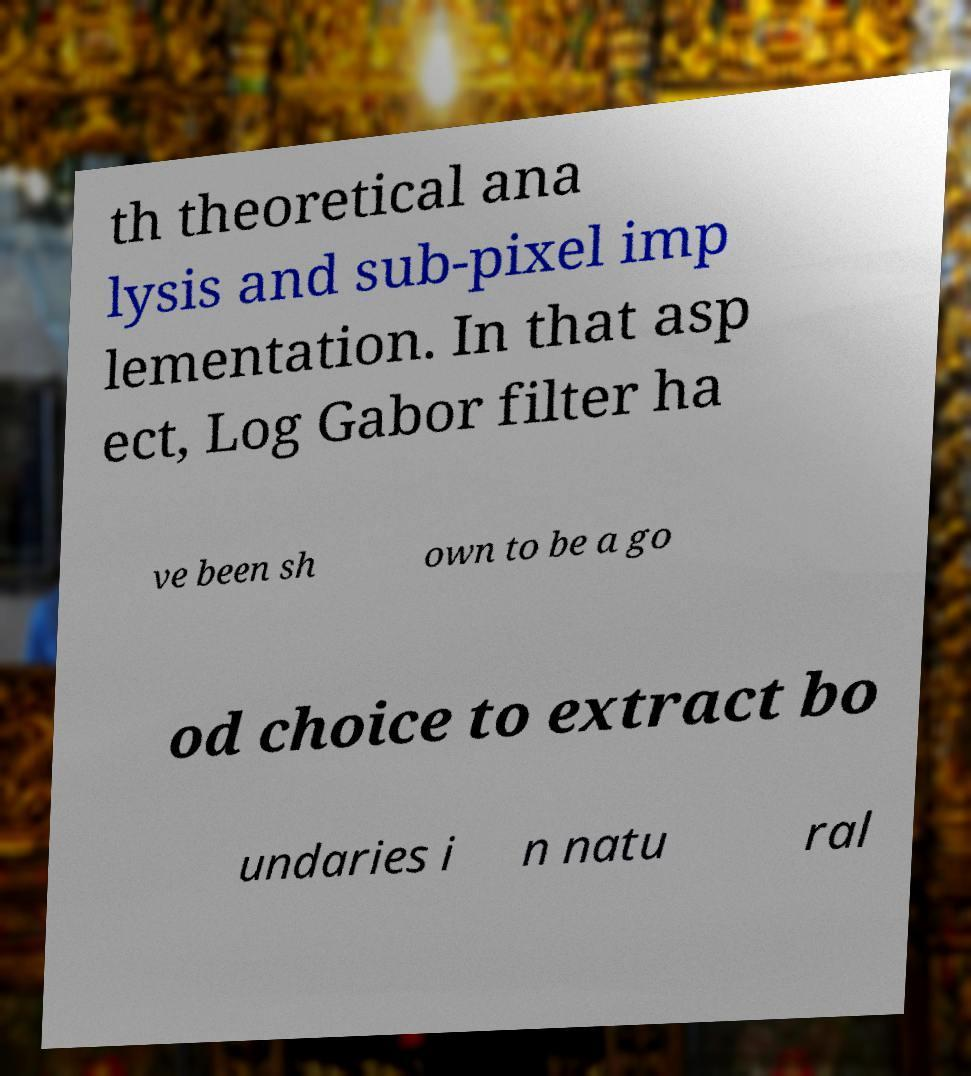For documentation purposes, I need the text within this image transcribed. Could you provide that? th theoretical ana lysis and sub-pixel imp lementation. In that asp ect, Log Gabor filter ha ve been sh own to be a go od choice to extract bo undaries i n natu ral 